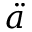<formula> <loc_0><loc_0><loc_500><loc_500>\ddot { a }</formula> 